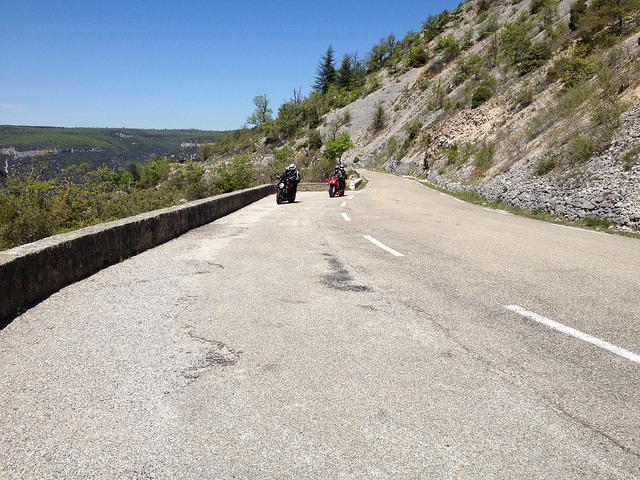What color is the vehicle on the right?
Select the accurate answer and provide explanation: 'Answer: answer
Rationale: rationale.'
Options: Red, green, blue, purple. Answer: red.
Rationale: There are two vehicles in the image and looking at it, it is clear which one is on the right and the color of that vehicle is red. 